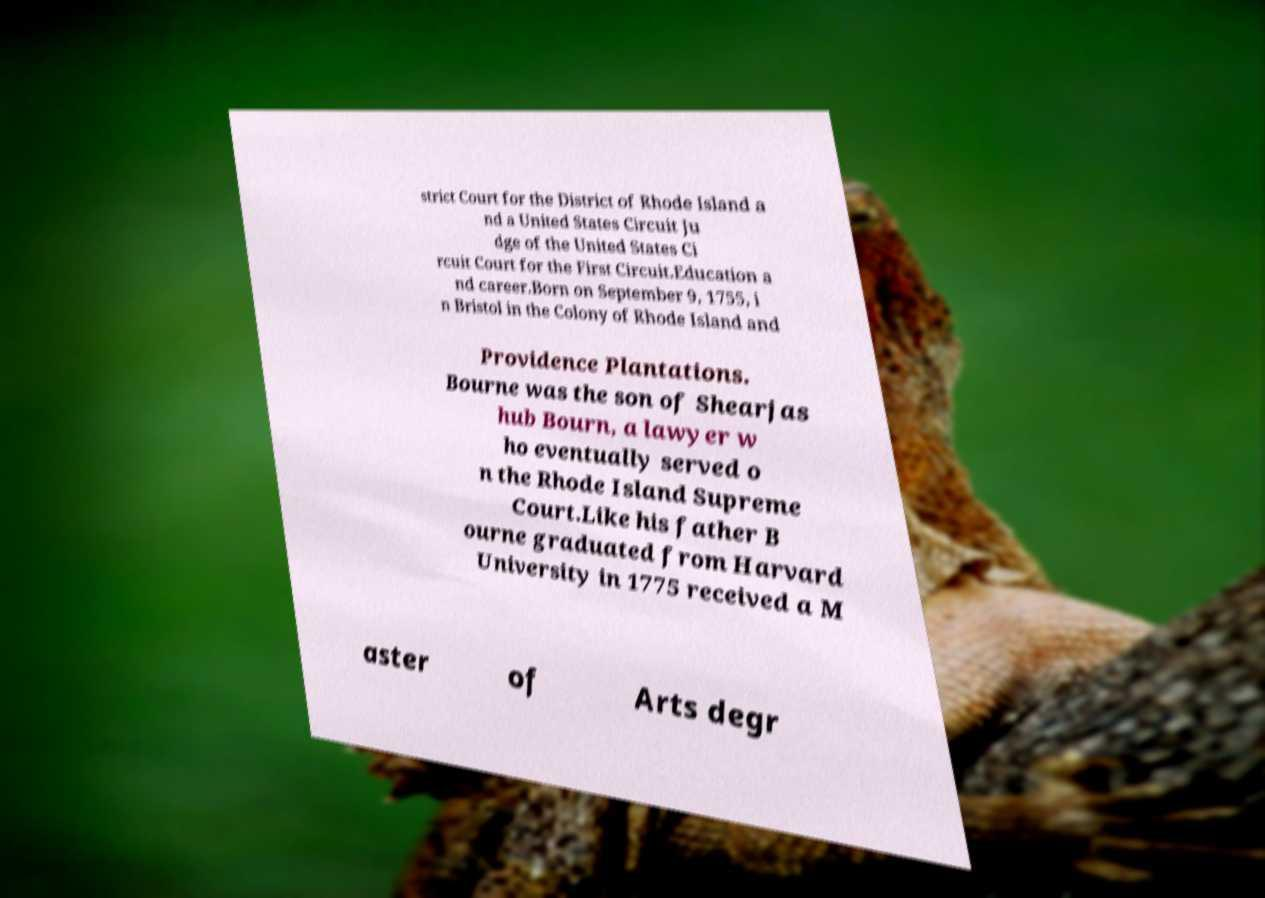I need the written content from this picture converted into text. Can you do that? strict Court for the District of Rhode Island a nd a United States Circuit Ju dge of the United States Ci rcuit Court for the First Circuit.Education a nd career.Born on September 9, 1755, i n Bristol in the Colony of Rhode Island and Providence Plantations. Bourne was the son of Shearjas hub Bourn, a lawyer w ho eventually served o n the Rhode Island Supreme Court.Like his father B ourne graduated from Harvard University in 1775 received a M aster of Arts degr 